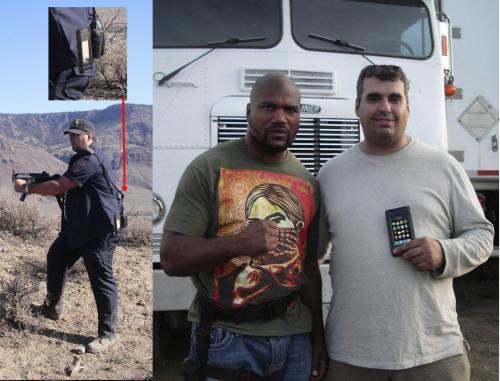What is the guy on the right holding in his hand?
Quick response, please. Phone. What is the picture on the person's shirt?
Give a very brief answer. Face. Is the climate dry?
Write a very short answer. Yes. Are two of them fixing something?
Quick response, please. No. Is the man to the right married?
Quick response, please. No. 